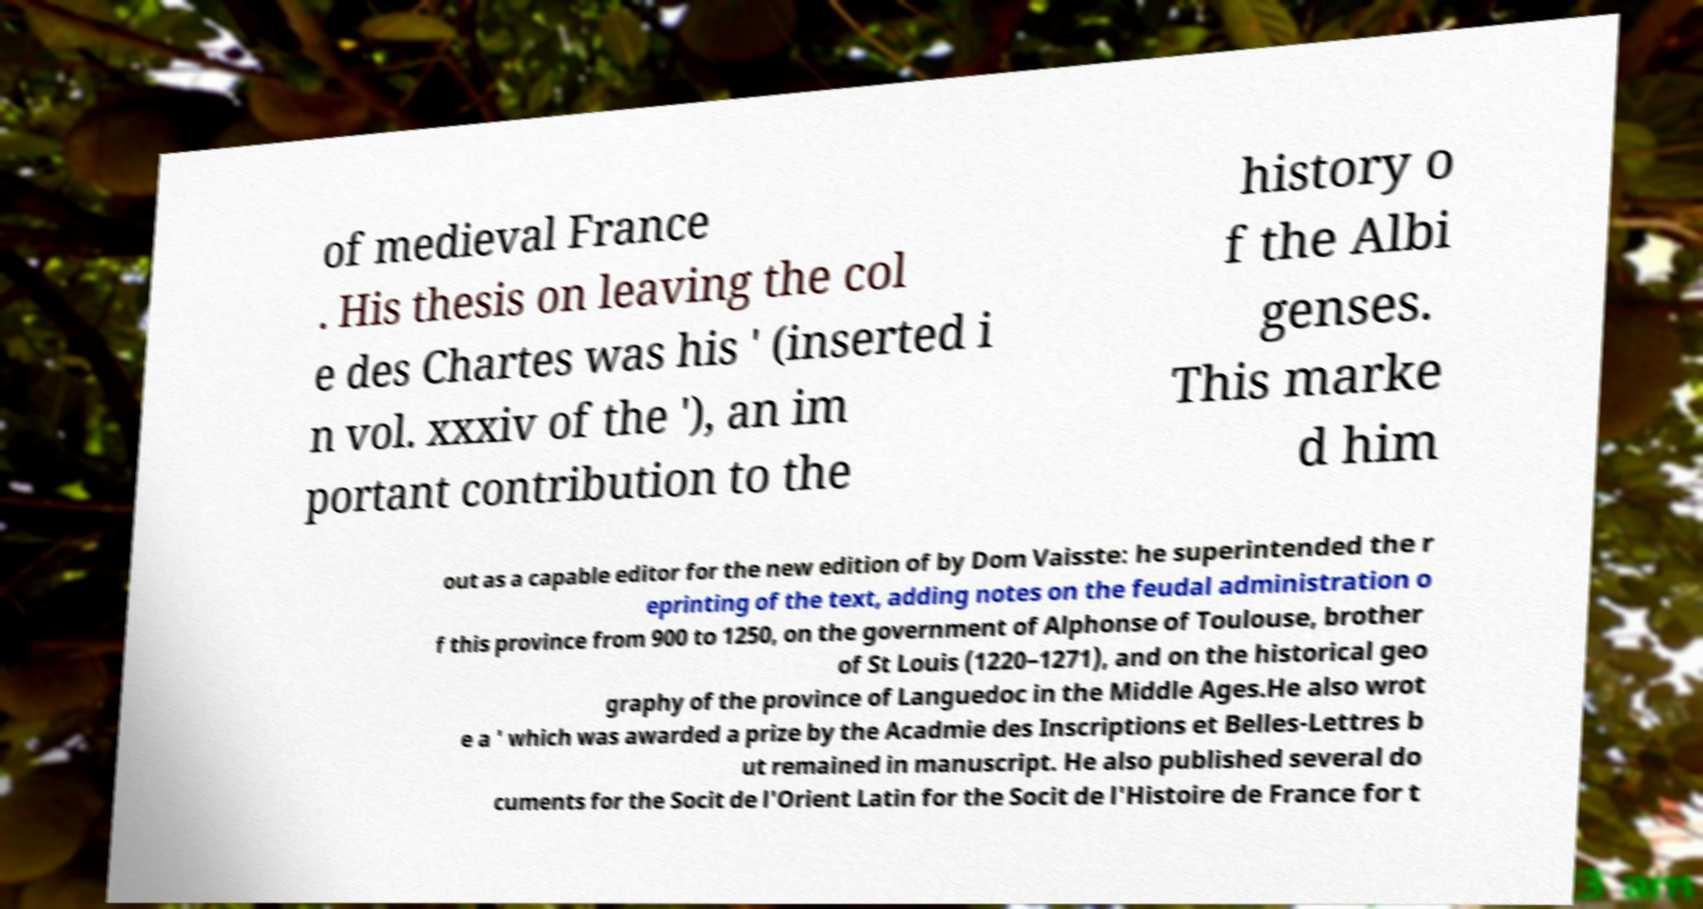I need the written content from this picture converted into text. Can you do that? of medieval France . His thesis on leaving the col e des Chartes was his ' (inserted i n vol. xxxiv of the '), an im portant contribution to the history o f the Albi genses. This marke d him out as a capable editor for the new edition of by Dom Vaisste: he superintended the r eprinting of the text, adding notes on the feudal administration o f this province from 900 to 1250, on the government of Alphonse of Toulouse, brother of St Louis (1220–1271), and on the historical geo graphy of the province of Languedoc in the Middle Ages.He also wrot e a ' which was awarded a prize by the Acadmie des Inscriptions et Belles-Lettres b ut remained in manuscript. He also published several do cuments for the Socit de l'Orient Latin for the Socit de l'Histoire de France for t 